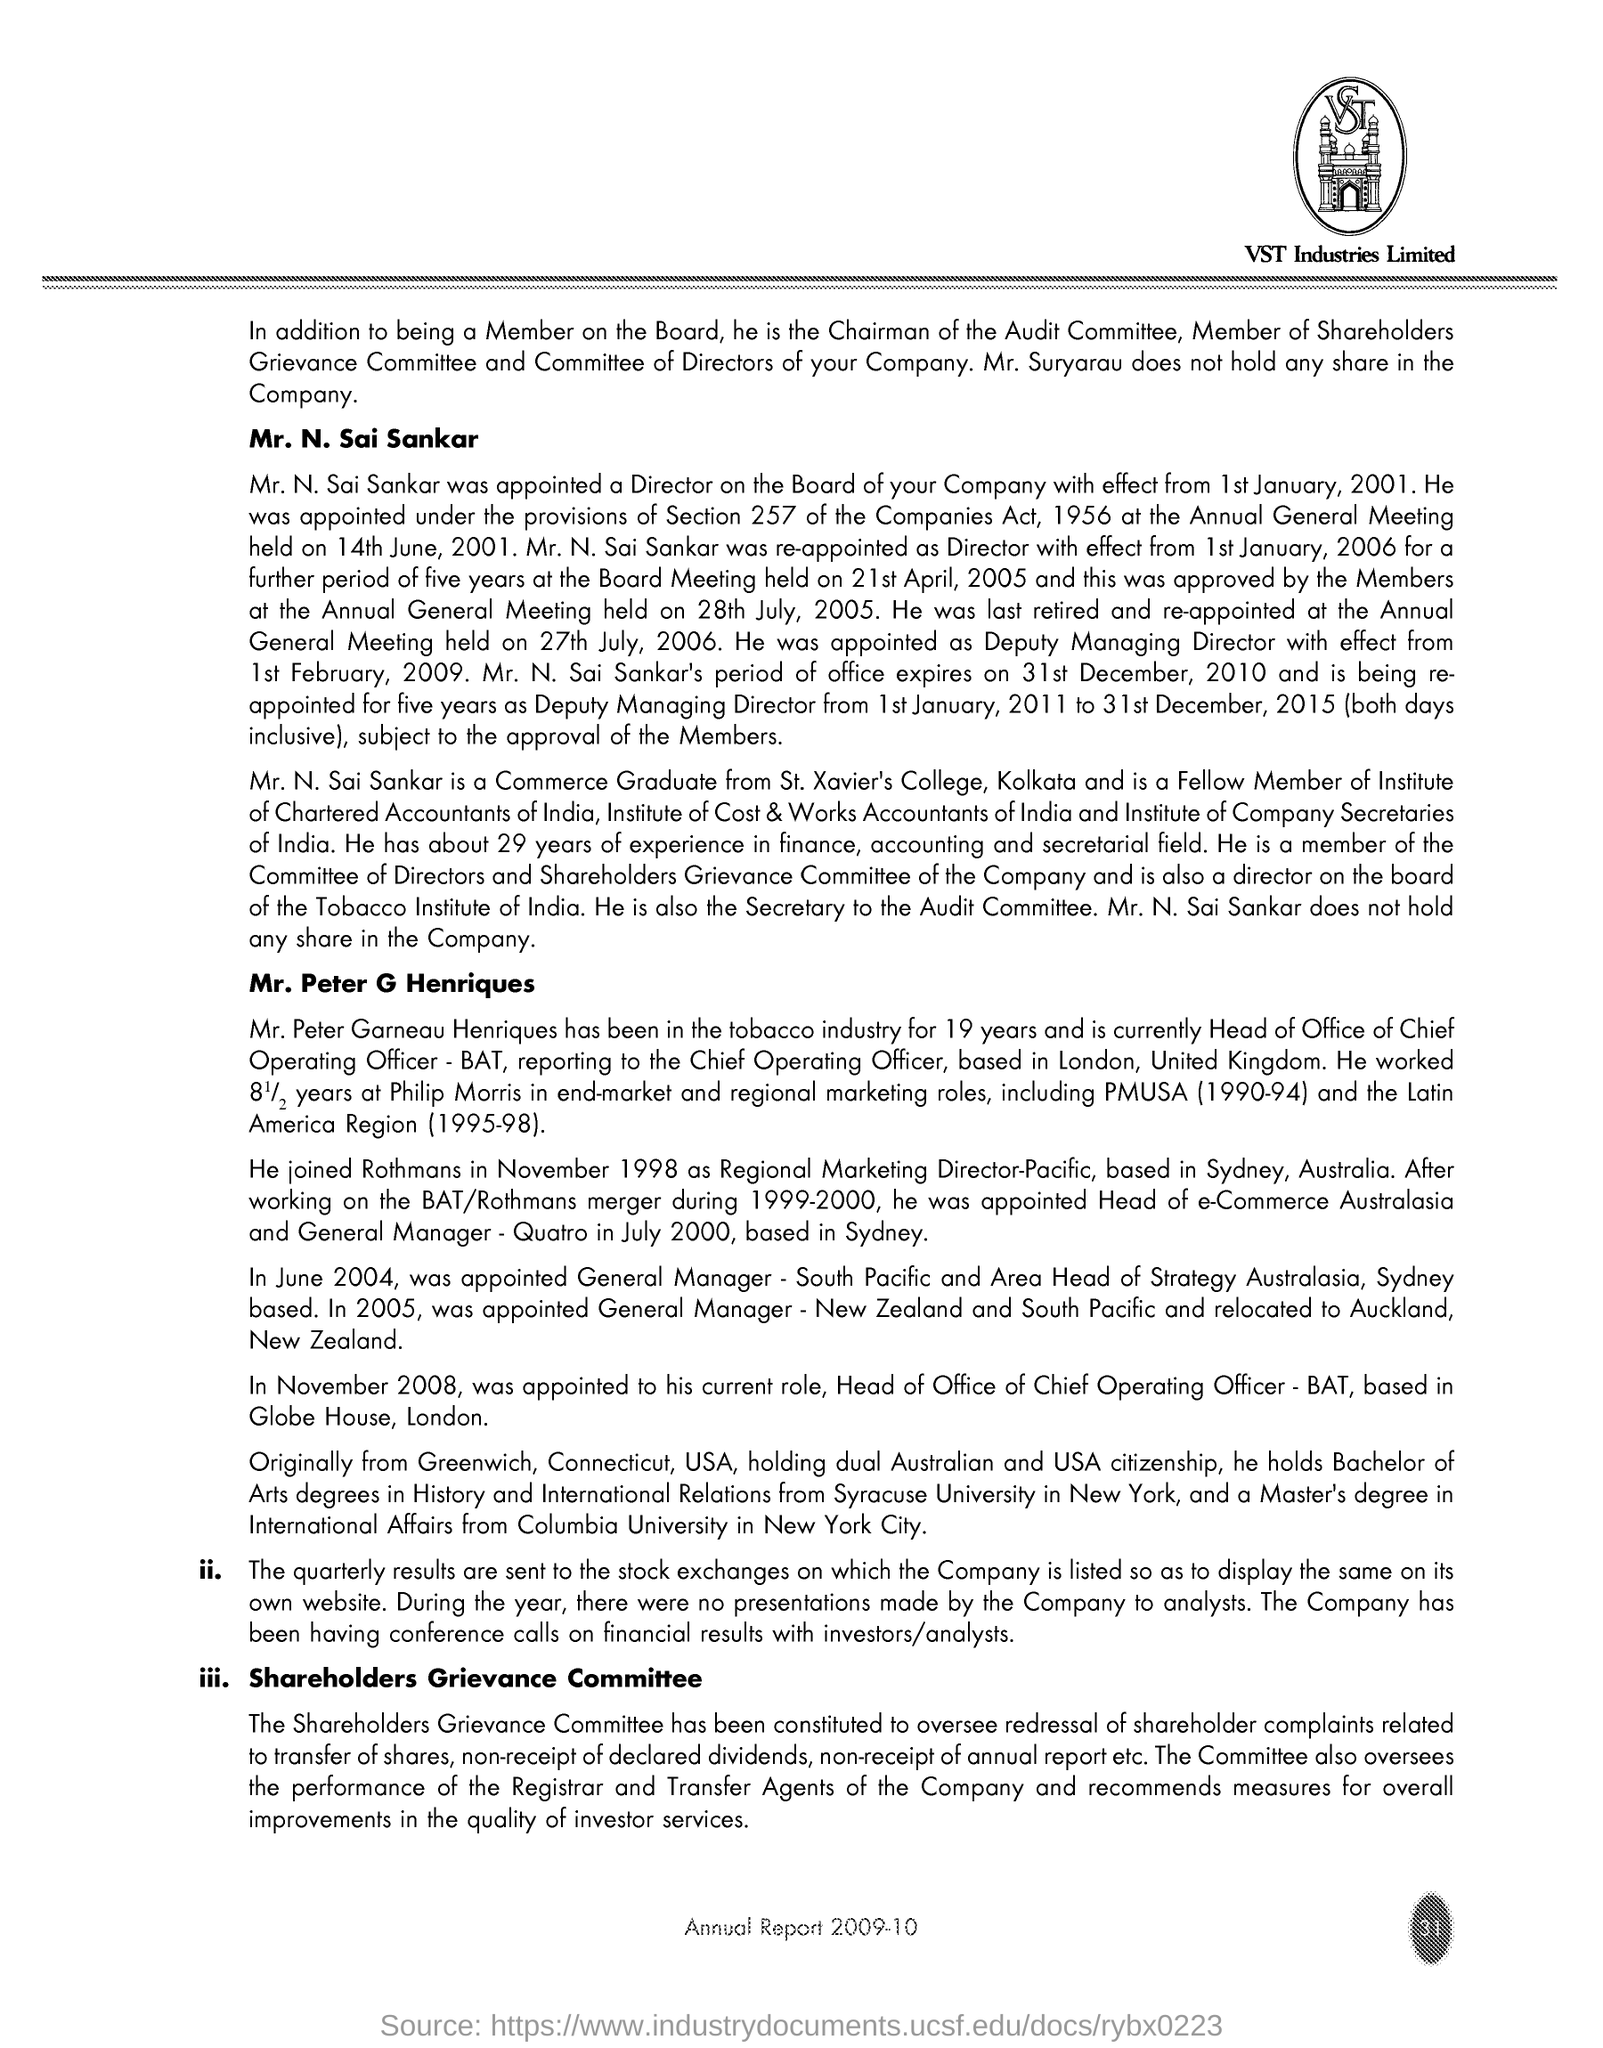What is the Page Number?
Make the answer very short. 31. Which text is in the image?
Provide a short and direct response. VST. What is written below the image?
Provide a short and direct response. VST Industries Limited. 